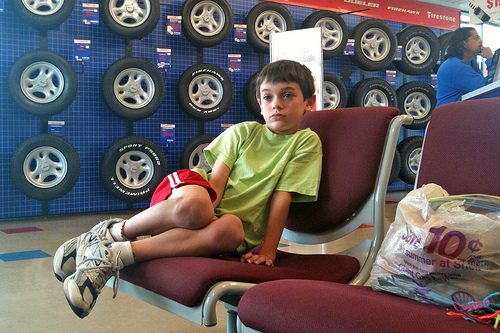<image>
Is the boy above the chair? No. The boy is not positioned above the chair. The vertical arrangement shows a different relationship. Where is the boy in relation to the chair? Is it behind the chair? No. The boy is not behind the chair. From this viewpoint, the boy appears to be positioned elsewhere in the scene. Where is the boy in relation to the chair? Is it on the chair? Yes. Looking at the image, I can see the boy is positioned on top of the chair, with the chair providing support. 